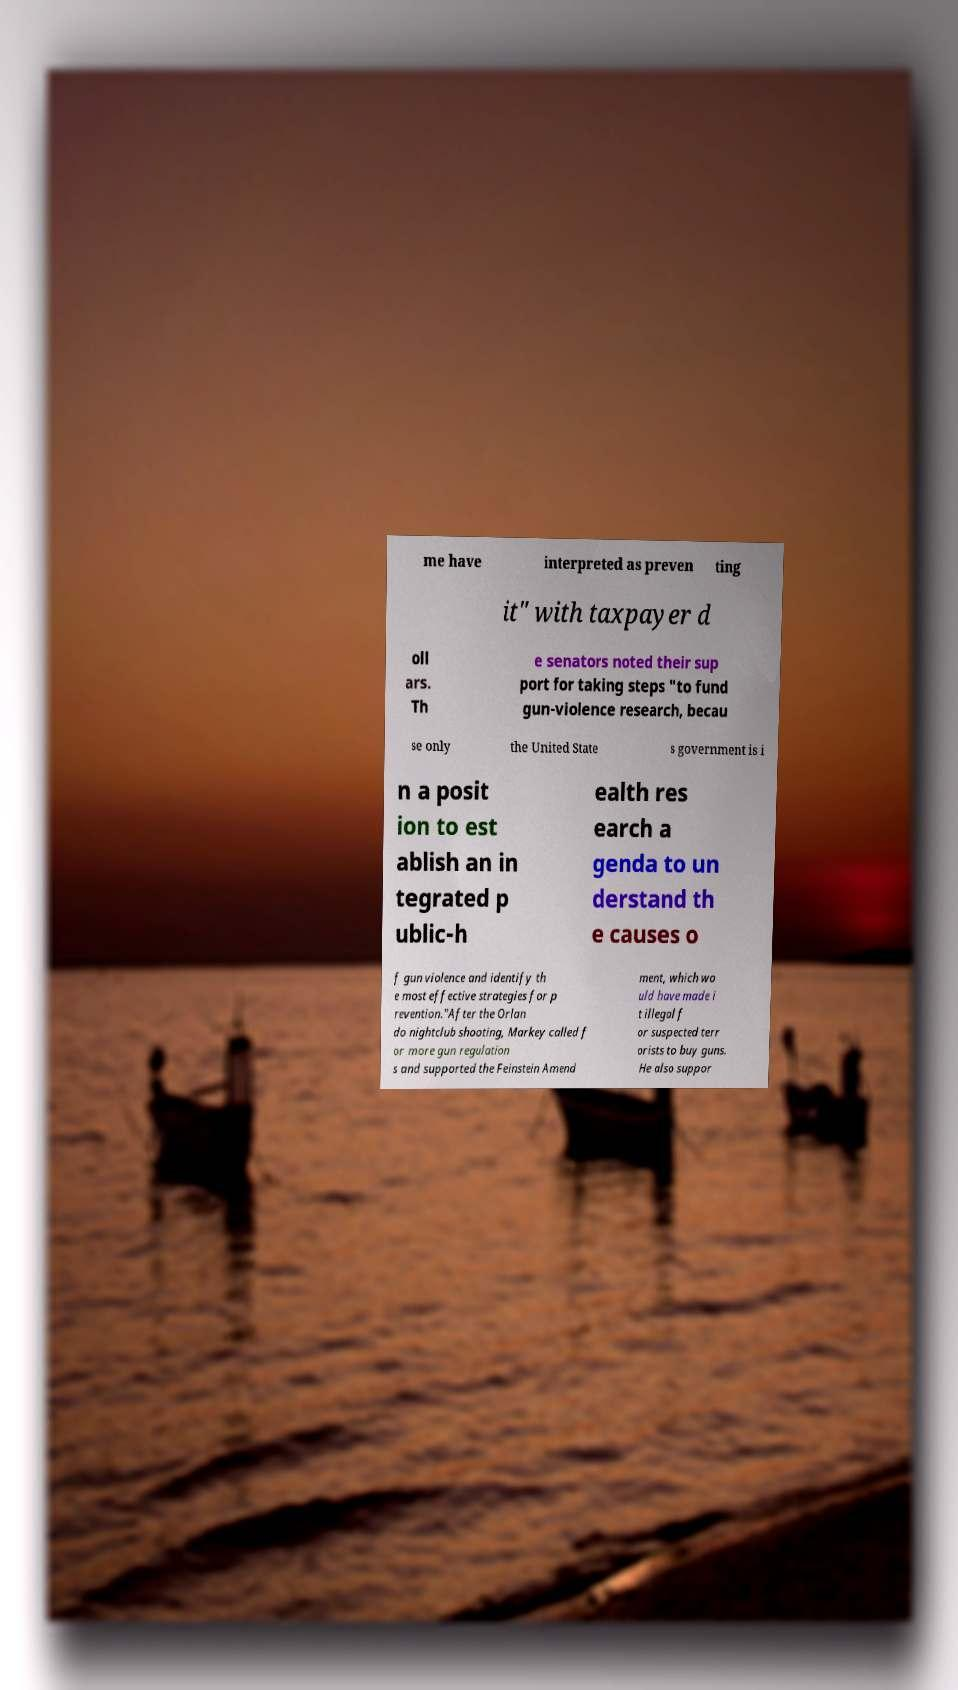Can you read and provide the text displayed in the image?This photo seems to have some interesting text. Can you extract and type it out for me? me have interpreted as preven ting it" with taxpayer d oll ars. Th e senators noted their sup port for taking steps "to fund gun-violence research, becau se only the United State s government is i n a posit ion to est ablish an in tegrated p ublic-h ealth res earch a genda to un derstand th e causes o f gun violence and identify th e most effective strategies for p revention."After the Orlan do nightclub shooting, Markey called f or more gun regulation s and supported the Feinstein Amend ment, which wo uld have made i t illegal f or suspected terr orists to buy guns. He also suppor 